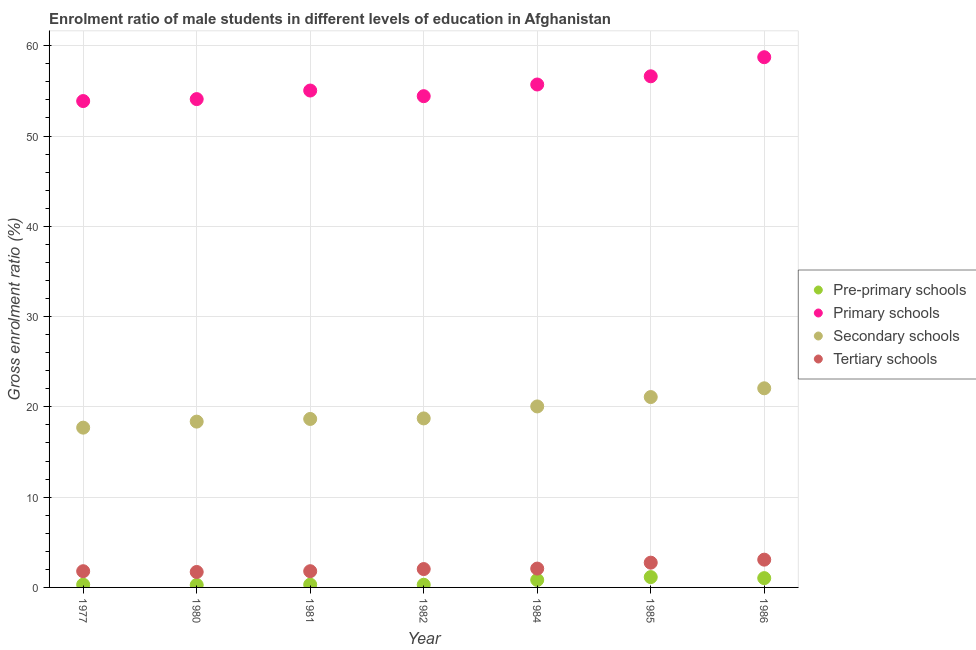What is the gross enrolment ratio(female) in pre-primary schools in 1985?
Ensure brevity in your answer.  1.14. Across all years, what is the maximum gross enrolment ratio(female) in secondary schools?
Your answer should be very brief. 22.06. Across all years, what is the minimum gross enrolment ratio(female) in pre-primary schools?
Offer a very short reply. 0.27. What is the total gross enrolment ratio(female) in secondary schools in the graph?
Provide a short and direct response. 136.64. What is the difference between the gross enrolment ratio(female) in tertiary schools in 1980 and that in 1981?
Offer a terse response. -0.09. What is the difference between the gross enrolment ratio(female) in secondary schools in 1981 and the gross enrolment ratio(female) in pre-primary schools in 1984?
Offer a terse response. 17.84. What is the average gross enrolment ratio(female) in tertiary schools per year?
Provide a succinct answer. 2.18. In the year 1986, what is the difference between the gross enrolment ratio(female) in secondary schools and gross enrolment ratio(female) in tertiary schools?
Your answer should be very brief. 18.98. In how many years, is the gross enrolment ratio(female) in tertiary schools greater than 12 %?
Your response must be concise. 0. What is the ratio of the gross enrolment ratio(female) in pre-primary schools in 1980 to that in 1982?
Provide a short and direct response. 0.92. Is the gross enrolment ratio(female) in pre-primary schools in 1980 less than that in 1986?
Provide a short and direct response. Yes. What is the difference between the highest and the second highest gross enrolment ratio(female) in pre-primary schools?
Keep it short and to the point. 0.12. What is the difference between the highest and the lowest gross enrolment ratio(female) in primary schools?
Offer a terse response. 4.86. In how many years, is the gross enrolment ratio(female) in secondary schools greater than the average gross enrolment ratio(female) in secondary schools taken over all years?
Give a very brief answer. 3. Is the sum of the gross enrolment ratio(female) in pre-primary schools in 1980 and 1985 greater than the maximum gross enrolment ratio(female) in tertiary schools across all years?
Offer a terse response. No. Is it the case that in every year, the sum of the gross enrolment ratio(female) in pre-primary schools and gross enrolment ratio(female) in secondary schools is greater than the sum of gross enrolment ratio(female) in primary schools and gross enrolment ratio(female) in tertiary schools?
Your answer should be compact. Yes. How many dotlines are there?
Your response must be concise. 4. What is the difference between two consecutive major ticks on the Y-axis?
Your response must be concise. 10. Does the graph contain grids?
Offer a very short reply. Yes. Where does the legend appear in the graph?
Ensure brevity in your answer.  Center right. How many legend labels are there?
Your answer should be very brief. 4. What is the title of the graph?
Your response must be concise. Enrolment ratio of male students in different levels of education in Afghanistan. Does "Methodology assessment" appear as one of the legend labels in the graph?
Provide a succinct answer. No. What is the label or title of the X-axis?
Provide a succinct answer. Year. What is the Gross enrolment ratio (%) of Pre-primary schools in 1977?
Give a very brief answer. 0.3. What is the Gross enrolment ratio (%) in Primary schools in 1977?
Offer a very short reply. 53.88. What is the Gross enrolment ratio (%) in Secondary schools in 1977?
Provide a succinct answer. 17.7. What is the Gross enrolment ratio (%) of Tertiary schools in 1977?
Offer a terse response. 1.8. What is the Gross enrolment ratio (%) in Pre-primary schools in 1980?
Give a very brief answer. 0.27. What is the Gross enrolment ratio (%) of Primary schools in 1980?
Keep it short and to the point. 54.09. What is the Gross enrolment ratio (%) in Secondary schools in 1980?
Provide a succinct answer. 18.37. What is the Gross enrolment ratio (%) of Tertiary schools in 1980?
Give a very brief answer. 1.71. What is the Gross enrolment ratio (%) in Pre-primary schools in 1981?
Offer a very short reply. 0.31. What is the Gross enrolment ratio (%) of Primary schools in 1981?
Make the answer very short. 55.04. What is the Gross enrolment ratio (%) in Secondary schools in 1981?
Offer a terse response. 18.66. What is the Gross enrolment ratio (%) of Tertiary schools in 1981?
Make the answer very short. 1.8. What is the Gross enrolment ratio (%) of Pre-primary schools in 1982?
Your answer should be compact. 0.29. What is the Gross enrolment ratio (%) in Primary schools in 1982?
Give a very brief answer. 54.42. What is the Gross enrolment ratio (%) of Secondary schools in 1982?
Keep it short and to the point. 18.72. What is the Gross enrolment ratio (%) of Tertiary schools in 1982?
Provide a succinct answer. 2.03. What is the Gross enrolment ratio (%) of Pre-primary schools in 1984?
Your answer should be compact. 0.83. What is the Gross enrolment ratio (%) of Primary schools in 1984?
Ensure brevity in your answer.  55.71. What is the Gross enrolment ratio (%) of Secondary schools in 1984?
Make the answer very short. 20.05. What is the Gross enrolment ratio (%) in Tertiary schools in 1984?
Give a very brief answer. 2.09. What is the Gross enrolment ratio (%) in Pre-primary schools in 1985?
Offer a terse response. 1.14. What is the Gross enrolment ratio (%) in Primary schools in 1985?
Provide a short and direct response. 56.62. What is the Gross enrolment ratio (%) in Secondary schools in 1985?
Offer a very short reply. 21.09. What is the Gross enrolment ratio (%) in Tertiary schools in 1985?
Your answer should be very brief. 2.74. What is the Gross enrolment ratio (%) of Pre-primary schools in 1986?
Your answer should be compact. 1.03. What is the Gross enrolment ratio (%) of Primary schools in 1986?
Ensure brevity in your answer.  58.73. What is the Gross enrolment ratio (%) of Secondary schools in 1986?
Your answer should be compact. 22.06. What is the Gross enrolment ratio (%) of Tertiary schools in 1986?
Your answer should be compact. 3.08. Across all years, what is the maximum Gross enrolment ratio (%) of Pre-primary schools?
Your answer should be compact. 1.14. Across all years, what is the maximum Gross enrolment ratio (%) of Primary schools?
Your response must be concise. 58.73. Across all years, what is the maximum Gross enrolment ratio (%) of Secondary schools?
Offer a terse response. 22.06. Across all years, what is the maximum Gross enrolment ratio (%) of Tertiary schools?
Provide a short and direct response. 3.08. Across all years, what is the minimum Gross enrolment ratio (%) in Pre-primary schools?
Give a very brief answer. 0.27. Across all years, what is the minimum Gross enrolment ratio (%) in Primary schools?
Your answer should be very brief. 53.88. Across all years, what is the minimum Gross enrolment ratio (%) of Secondary schools?
Provide a succinct answer. 17.7. Across all years, what is the minimum Gross enrolment ratio (%) in Tertiary schools?
Make the answer very short. 1.71. What is the total Gross enrolment ratio (%) in Pre-primary schools in the graph?
Offer a very short reply. 4.18. What is the total Gross enrolment ratio (%) in Primary schools in the graph?
Your response must be concise. 388.49. What is the total Gross enrolment ratio (%) in Secondary schools in the graph?
Provide a succinct answer. 136.64. What is the total Gross enrolment ratio (%) of Tertiary schools in the graph?
Make the answer very short. 15.25. What is the difference between the Gross enrolment ratio (%) in Pre-primary schools in 1977 and that in 1980?
Offer a terse response. 0.03. What is the difference between the Gross enrolment ratio (%) in Primary schools in 1977 and that in 1980?
Your answer should be compact. -0.22. What is the difference between the Gross enrolment ratio (%) in Secondary schools in 1977 and that in 1980?
Provide a succinct answer. -0.67. What is the difference between the Gross enrolment ratio (%) of Tertiary schools in 1977 and that in 1980?
Provide a succinct answer. 0.08. What is the difference between the Gross enrolment ratio (%) of Pre-primary schools in 1977 and that in 1981?
Ensure brevity in your answer.  -0. What is the difference between the Gross enrolment ratio (%) in Primary schools in 1977 and that in 1981?
Offer a very short reply. -1.17. What is the difference between the Gross enrolment ratio (%) in Secondary schools in 1977 and that in 1981?
Offer a terse response. -0.96. What is the difference between the Gross enrolment ratio (%) of Tertiary schools in 1977 and that in 1981?
Offer a terse response. -0. What is the difference between the Gross enrolment ratio (%) of Pre-primary schools in 1977 and that in 1982?
Provide a short and direct response. 0.01. What is the difference between the Gross enrolment ratio (%) of Primary schools in 1977 and that in 1982?
Your response must be concise. -0.54. What is the difference between the Gross enrolment ratio (%) of Secondary schools in 1977 and that in 1982?
Make the answer very short. -1.02. What is the difference between the Gross enrolment ratio (%) in Tertiary schools in 1977 and that in 1982?
Keep it short and to the point. -0.24. What is the difference between the Gross enrolment ratio (%) in Pre-primary schools in 1977 and that in 1984?
Make the answer very short. -0.52. What is the difference between the Gross enrolment ratio (%) in Primary schools in 1977 and that in 1984?
Your response must be concise. -1.83. What is the difference between the Gross enrolment ratio (%) of Secondary schools in 1977 and that in 1984?
Provide a short and direct response. -2.35. What is the difference between the Gross enrolment ratio (%) of Tertiary schools in 1977 and that in 1984?
Your answer should be very brief. -0.29. What is the difference between the Gross enrolment ratio (%) of Pre-primary schools in 1977 and that in 1985?
Keep it short and to the point. -0.84. What is the difference between the Gross enrolment ratio (%) in Primary schools in 1977 and that in 1985?
Make the answer very short. -2.74. What is the difference between the Gross enrolment ratio (%) in Secondary schools in 1977 and that in 1985?
Your answer should be very brief. -3.39. What is the difference between the Gross enrolment ratio (%) in Tertiary schools in 1977 and that in 1985?
Offer a very short reply. -0.95. What is the difference between the Gross enrolment ratio (%) in Pre-primary schools in 1977 and that in 1986?
Give a very brief answer. -0.72. What is the difference between the Gross enrolment ratio (%) in Primary schools in 1977 and that in 1986?
Your answer should be very brief. -4.86. What is the difference between the Gross enrolment ratio (%) in Secondary schools in 1977 and that in 1986?
Your response must be concise. -4.36. What is the difference between the Gross enrolment ratio (%) in Tertiary schools in 1977 and that in 1986?
Your answer should be very brief. -1.28. What is the difference between the Gross enrolment ratio (%) in Pre-primary schools in 1980 and that in 1981?
Provide a short and direct response. -0.04. What is the difference between the Gross enrolment ratio (%) of Primary schools in 1980 and that in 1981?
Offer a terse response. -0.95. What is the difference between the Gross enrolment ratio (%) in Secondary schools in 1980 and that in 1981?
Ensure brevity in your answer.  -0.3. What is the difference between the Gross enrolment ratio (%) in Tertiary schools in 1980 and that in 1981?
Provide a short and direct response. -0.09. What is the difference between the Gross enrolment ratio (%) of Pre-primary schools in 1980 and that in 1982?
Keep it short and to the point. -0.02. What is the difference between the Gross enrolment ratio (%) of Primary schools in 1980 and that in 1982?
Make the answer very short. -0.32. What is the difference between the Gross enrolment ratio (%) in Secondary schools in 1980 and that in 1982?
Make the answer very short. -0.35. What is the difference between the Gross enrolment ratio (%) in Tertiary schools in 1980 and that in 1982?
Your response must be concise. -0.32. What is the difference between the Gross enrolment ratio (%) in Pre-primary schools in 1980 and that in 1984?
Your answer should be compact. -0.56. What is the difference between the Gross enrolment ratio (%) of Primary schools in 1980 and that in 1984?
Give a very brief answer. -1.62. What is the difference between the Gross enrolment ratio (%) in Secondary schools in 1980 and that in 1984?
Provide a succinct answer. -1.68. What is the difference between the Gross enrolment ratio (%) of Tertiary schools in 1980 and that in 1984?
Give a very brief answer. -0.37. What is the difference between the Gross enrolment ratio (%) in Pre-primary schools in 1980 and that in 1985?
Keep it short and to the point. -0.87. What is the difference between the Gross enrolment ratio (%) in Primary schools in 1980 and that in 1985?
Your response must be concise. -2.53. What is the difference between the Gross enrolment ratio (%) in Secondary schools in 1980 and that in 1985?
Ensure brevity in your answer.  -2.72. What is the difference between the Gross enrolment ratio (%) in Tertiary schools in 1980 and that in 1985?
Offer a very short reply. -1.03. What is the difference between the Gross enrolment ratio (%) of Pre-primary schools in 1980 and that in 1986?
Your answer should be compact. -0.76. What is the difference between the Gross enrolment ratio (%) in Primary schools in 1980 and that in 1986?
Provide a succinct answer. -4.64. What is the difference between the Gross enrolment ratio (%) in Secondary schools in 1980 and that in 1986?
Ensure brevity in your answer.  -3.69. What is the difference between the Gross enrolment ratio (%) of Tertiary schools in 1980 and that in 1986?
Provide a short and direct response. -1.36. What is the difference between the Gross enrolment ratio (%) in Pre-primary schools in 1981 and that in 1982?
Keep it short and to the point. 0.01. What is the difference between the Gross enrolment ratio (%) in Secondary schools in 1981 and that in 1982?
Your response must be concise. -0.06. What is the difference between the Gross enrolment ratio (%) in Tertiary schools in 1981 and that in 1982?
Give a very brief answer. -0.24. What is the difference between the Gross enrolment ratio (%) in Pre-primary schools in 1981 and that in 1984?
Your answer should be very brief. -0.52. What is the difference between the Gross enrolment ratio (%) of Primary schools in 1981 and that in 1984?
Give a very brief answer. -0.67. What is the difference between the Gross enrolment ratio (%) of Secondary schools in 1981 and that in 1984?
Ensure brevity in your answer.  -1.39. What is the difference between the Gross enrolment ratio (%) of Tertiary schools in 1981 and that in 1984?
Make the answer very short. -0.29. What is the difference between the Gross enrolment ratio (%) in Pre-primary schools in 1981 and that in 1985?
Your answer should be very brief. -0.84. What is the difference between the Gross enrolment ratio (%) in Primary schools in 1981 and that in 1985?
Make the answer very short. -1.58. What is the difference between the Gross enrolment ratio (%) in Secondary schools in 1981 and that in 1985?
Give a very brief answer. -2.42. What is the difference between the Gross enrolment ratio (%) in Tertiary schools in 1981 and that in 1985?
Give a very brief answer. -0.95. What is the difference between the Gross enrolment ratio (%) of Pre-primary schools in 1981 and that in 1986?
Keep it short and to the point. -0.72. What is the difference between the Gross enrolment ratio (%) of Primary schools in 1981 and that in 1986?
Offer a terse response. -3.69. What is the difference between the Gross enrolment ratio (%) of Secondary schools in 1981 and that in 1986?
Your answer should be compact. -3.4. What is the difference between the Gross enrolment ratio (%) in Tertiary schools in 1981 and that in 1986?
Give a very brief answer. -1.28. What is the difference between the Gross enrolment ratio (%) of Pre-primary schools in 1982 and that in 1984?
Provide a short and direct response. -0.53. What is the difference between the Gross enrolment ratio (%) in Primary schools in 1982 and that in 1984?
Provide a short and direct response. -1.29. What is the difference between the Gross enrolment ratio (%) of Secondary schools in 1982 and that in 1984?
Offer a terse response. -1.33. What is the difference between the Gross enrolment ratio (%) of Tertiary schools in 1982 and that in 1984?
Your response must be concise. -0.05. What is the difference between the Gross enrolment ratio (%) of Pre-primary schools in 1982 and that in 1985?
Keep it short and to the point. -0.85. What is the difference between the Gross enrolment ratio (%) of Primary schools in 1982 and that in 1985?
Give a very brief answer. -2.2. What is the difference between the Gross enrolment ratio (%) in Secondary schools in 1982 and that in 1985?
Provide a short and direct response. -2.36. What is the difference between the Gross enrolment ratio (%) of Tertiary schools in 1982 and that in 1985?
Offer a very short reply. -0.71. What is the difference between the Gross enrolment ratio (%) of Pre-primary schools in 1982 and that in 1986?
Your response must be concise. -0.73. What is the difference between the Gross enrolment ratio (%) of Primary schools in 1982 and that in 1986?
Your response must be concise. -4.32. What is the difference between the Gross enrolment ratio (%) of Secondary schools in 1982 and that in 1986?
Provide a succinct answer. -3.34. What is the difference between the Gross enrolment ratio (%) of Tertiary schools in 1982 and that in 1986?
Ensure brevity in your answer.  -1.04. What is the difference between the Gross enrolment ratio (%) of Pre-primary schools in 1984 and that in 1985?
Ensure brevity in your answer.  -0.32. What is the difference between the Gross enrolment ratio (%) of Primary schools in 1984 and that in 1985?
Your response must be concise. -0.91. What is the difference between the Gross enrolment ratio (%) of Secondary schools in 1984 and that in 1985?
Make the answer very short. -1.04. What is the difference between the Gross enrolment ratio (%) of Tertiary schools in 1984 and that in 1985?
Offer a very short reply. -0.66. What is the difference between the Gross enrolment ratio (%) of Pre-primary schools in 1984 and that in 1986?
Offer a very short reply. -0.2. What is the difference between the Gross enrolment ratio (%) in Primary schools in 1984 and that in 1986?
Your response must be concise. -3.02. What is the difference between the Gross enrolment ratio (%) of Secondary schools in 1984 and that in 1986?
Your answer should be very brief. -2.01. What is the difference between the Gross enrolment ratio (%) of Tertiary schools in 1984 and that in 1986?
Give a very brief answer. -0.99. What is the difference between the Gross enrolment ratio (%) of Pre-primary schools in 1985 and that in 1986?
Your answer should be very brief. 0.12. What is the difference between the Gross enrolment ratio (%) of Primary schools in 1985 and that in 1986?
Your response must be concise. -2.11. What is the difference between the Gross enrolment ratio (%) of Secondary schools in 1985 and that in 1986?
Your response must be concise. -0.97. What is the difference between the Gross enrolment ratio (%) in Tertiary schools in 1985 and that in 1986?
Provide a short and direct response. -0.33. What is the difference between the Gross enrolment ratio (%) of Pre-primary schools in 1977 and the Gross enrolment ratio (%) of Primary schools in 1980?
Your answer should be very brief. -53.79. What is the difference between the Gross enrolment ratio (%) in Pre-primary schools in 1977 and the Gross enrolment ratio (%) in Secondary schools in 1980?
Ensure brevity in your answer.  -18.06. What is the difference between the Gross enrolment ratio (%) in Pre-primary schools in 1977 and the Gross enrolment ratio (%) in Tertiary schools in 1980?
Provide a succinct answer. -1.41. What is the difference between the Gross enrolment ratio (%) in Primary schools in 1977 and the Gross enrolment ratio (%) in Secondary schools in 1980?
Provide a short and direct response. 35.51. What is the difference between the Gross enrolment ratio (%) in Primary schools in 1977 and the Gross enrolment ratio (%) in Tertiary schools in 1980?
Keep it short and to the point. 52.16. What is the difference between the Gross enrolment ratio (%) in Secondary schools in 1977 and the Gross enrolment ratio (%) in Tertiary schools in 1980?
Your answer should be very brief. 15.99. What is the difference between the Gross enrolment ratio (%) in Pre-primary schools in 1977 and the Gross enrolment ratio (%) in Primary schools in 1981?
Ensure brevity in your answer.  -54.74. What is the difference between the Gross enrolment ratio (%) in Pre-primary schools in 1977 and the Gross enrolment ratio (%) in Secondary schools in 1981?
Offer a very short reply. -18.36. What is the difference between the Gross enrolment ratio (%) of Pre-primary schools in 1977 and the Gross enrolment ratio (%) of Tertiary schools in 1981?
Ensure brevity in your answer.  -1.49. What is the difference between the Gross enrolment ratio (%) in Primary schools in 1977 and the Gross enrolment ratio (%) in Secondary schools in 1981?
Provide a short and direct response. 35.21. What is the difference between the Gross enrolment ratio (%) of Primary schools in 1977 and the Gross enrolment ratio (%) of Tertiary schools in 1981?
Your answer should be compact. 52.08. What is the difference between the Gross enrolment ratio (%) in Secondary schools in 1977 and the Gross enrolment ratio (%) in Tertiary schools in 1981?
Your answer should be compact. 15.9. What is the difference between the Gross enrolment ratio (%) of Pre-primary schools in 1977 and the Gross enrolment ratio (%) of Primary schools in 1982?
Ensure brevity in your answer.  -54.11. What is the difference between the Gross enrolment ratio (%) in Pre-primary schools in 1977 and the Gross enrolment ratio (%) in Secondary schools in 1982?
Your answer should be compact. -18.42. What is the difference between the Gross enrolment ratio (%) in Pre-primary schools in 1977 and the Gross enrolment ratio (%) in Tertiary schools in 1982?
Your response must be concise. -1.73. What is the difference between the Gross enrolment ratio (%) in Primary schools in 1977 and the Gross enrolment ratio (%) in Secondary schools in 1982?
Your answer should be very brief. 35.15. What is the difference between the Gross enrolment ratio (%) of Primary schools in 1977 and the Gross enrolment ratio (%) of Tertiary schools in 1982?
Your answer should be very brief. 51.84. What is the difference between the Gross enrolment ratio (%) of Secondary schools in 1977 and the Gross enrolment ratio (%) of Tertiary schools in 1982?
Your response must be concise. 15.66. What is the difference between the Gross enrolment ratio (%) in Pre-primary schools in 1977 and the Gross enrolment ratio (%) in Primary schools in 1984?
Your response must be concise. -55.41. What is the difference between the Gross enrolment ratio (%) of Pre-primary schools in 1977 and the Gross enrolment ratio (%) of Secondary schools in 1984?
Your response must be concise. -19.74. What is the difference between the Gross enrolment ratio (%) in Pre-primary schools in 1977 and the Gross enrolment ratio (%) in Tertiary schools in 1984?
Ensure brevity in your answer.  -1.78. What is the difference between the Gross enrolment ratio (%) in Primary schools in 1977 and the Gross enrolment ratio (%) in Secondary schools in 1984?
Provide a succinct answer. 33.83. What is the difference between the Gross enrolment ratio (%) in Primary schools in 1977 and the Gross enrolment ratio (%) in Tertiary schools in 1984?
Provide a short and direct response. 51.79. What is the difference between the Gross enrolment ratio (%) of Secondary schools in 1977 and the Gross enrolment ratio (%) of Tertiary schools in 1984?
Offer a terse response. 15.61. What is the difference between the Gross enrolment ratio (%) of Pre-primary schools in 1977 and the Gross enrolment ratio (%) of Primary schools in 1985?
Give a very brief answer. -56.31. What is the difference between the Gross enrolment ratio (%) of Pre-primary schools in 1977 and the Gross enrolment ratio (%) of Secondary schools in 1985?
Offer a very short reply. -20.78. What is the difference between the Gross enrolment ratio (%) in Pre-primary schools in 1977 and the Gross enrolment ratio (%) in Tertiary schools in 1985?
Give a very brief answer. -2.44. What is the difference between the Gross enrolment ratio (%) of Primary schools in 1977 and the Gross enrolment ratio (%) of Secondary schools in 1985?
Give a very brief answer. 32.79. What is the difference between the Gross enrolment ratio (%) in Primary schools in 1977 and the Gross enrolment ratio (%) in Tertiary schools in 1985?
Your answer should be very brief. 51.13. What is the difference between the Gross enrolment ratio (%) in Secondary schools in 1977 and the Gross enrolment ratio (%) in Tertiary schools in 1985?
Provide a succinct answer. 14.96. What is the difference between the Gross enrolment ratio (%) in Pre-primary schools in 1977 and the Gross enrolment ratio (%) in Primary schools in 1986?
Your answer should be compact. -58.43. What is the difference between the Gross enrolment ratio (%) in Pre-primary schools in 1977 and the Gross enrolment ratio (%) in Secondary schools in 1986?
Provide a succinct answer. -21.75. What is the difference between the Gross enrolment ratio (%) in Pre-primary schools in 1977 and the Gross enrolment ratio (%) in Tertiary schools in 1986?
Your answer should be very brief. -2.77. What is the difference between the Gross enrolment ratio (%) in Primary schools in 1977 and the Gross enrolment ratio (%) in Secondary schools in 1986?
Provide a succinct answer. 31.82. What is the difference between the Gross enrolment ratio (%) of Primary schools in 1977 and the Gross enrolment ratio (%) of Tertiary schools in 1986?
Make the answer very short. 50.8. What is the difference between the Gross enrolment ratio (%) of Secondary schools in 1977 and the Gross enrolment ratio (%) of Tertiary schools in 1986?
Offer a very short reply. 14.62. What is the difference between the Gross enrolment ratio (%) in Pre-primary schools in 1980 and the Gross enrolment ratio (%) in Primary schools in 1981?
Ensure brevity in your answer.  -54.77. What is the difference between the Gross enrolment ratio (%) of Pre-primary schools in 1980 and the Gross enrolment ratio (%) of Secondary schools in 1981?
Offer a terse response. -18.39. What is the difference between the Gross enrolment ratio (%) of Pre-primary schools in 1980 and the Gross enrolment ratio (%) of Tertiary schools in 1981?
Your answer should be compact. -1.53. What is the difference between the Gross enrolment ratio (%) of Primary schools in 1980 and the Gross enrolment ratio (%) of Secondary schools in 1981?
Your response must be concise. 35.43. What is the difference between the Gross enrolment ratio (%) of Primary schools in 1980 and the Gross enrolment ratio (%) of Tertiary schools in 1981?
Ensure brevity in your answer.  52.29. What is the difference between the Gross enrolment ratio (%) in Secondary schools in 1980 and the Gross enrolment ratio (%) in Tertiary schools in 1981?
Provide a succinct answer. 16.57. What is the difference between the Gross enrolment ratio (%) of Pre-primary schools in 1980 and the Gross enrolment ratio (%) of Primary schools in 1982?
Your response must be concise. -54.15. What is the difference between the Gross enrolment ratio (%) of Pre-primary schools in 1980 and the Gross enrolment ratio (%) of Secondary schools in 1982?
Offer a terse response. -18.45. What is the difference between the Gross enrolment ratio (%) of Pre-primary schools in 1980 and the Gross enrolment ratio (%) of Tertiary schools in 1982?
Your answer should be very brief. -1.76. What is the difference between the Gross enrolment ratio (%) of Primary schools in 1980 and the Gross enrolment ratio (%) of Secondary schools in 1982?
Keep it short and to the point. 35.37. What is the difference between the Gross enrolment ratio (%) of Primary schools in 1980 and the Gross enrolment ratio (%) of Tertiary schools in 1982?
Make the answer very short. 52.06. What is the difference between the Gross enrolment ratio (%) in Secondary schools in 1980 and the Gross enrolment ratio (%) in Tertiary schools in 1982?
Your answer should be very brief. 16.33. What is the difference between the Gross enrolment ratio (%) in Pre-primary schools in 1980 and the Gross enrolment ratio (%) in Primary schools in 1984?
Give a very brief answer. -55.44. What is the difference between the Gross enrolment ratio (%) of Pre-primary schools in 1980 and the Gross enrolment ratio (%) of Secondary schools in 1984?
Your answer should be compact. -19.78. What is the difference between the Gross enrolment ratio (%) of Pre-primary schools in 1980 and the Gross enrolment ratio (%) of Tertiary schools in 1984?
Give a very brief answer. -1.82. What is the difference between the Gross enrolment ratio (%) of Primary schools in 1980 and the Gross enrolment ratio (%) of Secondary schools in 1984?
Keep it short and to the point. 34.04. What is the difference between the Gross enrolment ratio (%) of Primary schools in 1980 and the Gross enrolment ratio (%) of Tertiary schools in 1984?
Offer a very short reply. 52.01. What is the difference between the Gross enrolment ratio (%) in Secondary schools in 1980 and the Gross enrolment ratio (%) in Tertiary schools in 1984?
Offer a very short reply. 16.28. What is the difference between the Gross enrolment ratio (%) of Pre-primary schools in 1980 and the Gross enrolment ratio (%) of Primary schools in 1985?
Your answer should be very brief. -56.35. What is the difference between the Gross enrolment ratio (%) in Pre-primary schools in 1980 and the Gross enrolment ratio (%) in Secondary schools in 1985?
Offer a terse response. -20.82. What is the difference between the Gross enrolment ratio (%) of Pre-primary schools in 1980 and the Gross enrolment ratio (%) of Tertiary schools in 1985?
Keep it short and to the point. -2.47. What is the difference between the Gross enrolment ratio (%) of Primary schools in 1980 and the Gross enrolment ratio (%) of Secondary schools in 1985?
Keep it short and to the point. 33.01. What is the difference between the Gross enrolment ratio (%) of Primary schools in 1980 and the Gross enrolment ratio (%) of Tertiary schools in 1985?
Provide a short and direct response. 51.35. What is the difference between the Gross enrolment ratio (%) of Secondary schools in 1980 and the Gross enrolment ratio (%) of Tertiary schools in 1985?
Offer a terse response. 15.62. What is the difference between the Gross enrolment ratio (%) of Pre-primary schools in 1980 and the Gross enrolment ratio (%) of Primary schools in 1986?
Your response must be concise. -58.46. What is the difference between the Gross enrolment ratio (%) in Pre-primary schools in 1980 and the Gross enrolment ratio (%) in Secondary schools in 1986?
Make the answer very short. -21.79. What is the difference between the Gross enrolment ratio (%) of Pre-primary schools in 1980 and the Gross enrolment ratio (%) of Tertiary schools in 1986?
Give a very brief answer. -2.81. What is the difference between the Gross enrolment ratio (%) of Primary schools in 1980 and the Gross enrolment ratio (%) of Secondary schools in 1986?
Your answer should be very brief. 32.03. What is the difference between the Gross enrolment ratio (%) of Primary schools in 1980 and the Gross enrolment ratio (%) of Tertiary schools in 1986?
Keep it short and to the point. 51.02. What is the difference between the Gross enrolment ratio (%) in Secondary schools in 1980 and the Gross enrolment ratio (%) in Tertiary schools in 1986?
Your answer should be very brief. 15.29. What is the difference between the Gross enrolment ratio (%) in Pre-primary schools in 1981 and the Gross enrolment ratio (%) in Primary schools in 1982?
Your answer should be very brief. -54.11. What is the difference between the Gross enrolment ratio (%) in Pre-primary schools in 1981 and the Gross enrolment ratio (%) in Secondary schools in 1982?
Give a very brief answer. -18.41. What is the difference between the Gross enrolment ratio (%) in Pre-primary schools in 1981 and the Gross enrolment ratio (%) in Tertiary schools in 1982?
Make the answer very short. -1.73. What is the difference between the Gross enrolment ratio (%) in Primary schools in 1981 and the Gross enrolment ratio (%) in Secondary schools in 1982?
Your answer should be compact. 36.32. What is the difference between the Gross enrolment ratio (%) in Primary schools in 1981 and the Gross enrolment ratio (%) in Tertiary schools in 1982?
Your answer should be very brief. 53.01. What is the difference between the Gross enrolment ratio (%) in Secondary schools in 1981 and the Gross enrolment ratio (%) in Tertiary schools in 1982?
Ensure brevity in your answer.  16.63. What is the difference between the Gross enrolment ratio (%) in Pre-primary schools in 1981 and the Gross enrolment ratio (%) in Primary schools in 1984?
Make the answer very short. -55.4. What is the difference between the Gross enrolment ratio (%) of Pre-primary schools in 1981 and the Gross enrolment ratio (%) of Secondary schools in 1984?
Offer a terse response. -19.74. What is the difference between the Gross enrolment ratio (%) in Pre-primary schools in 1981 and the Gross enrolment ratio (%) in Tertiary schools in 1984?
Give a very brief answer. -1.78. What is the difference between the Gross enrolment ratio (%) of Primary schools in 1981 and the Gross enrolment ratio (%) of Secondary schools in 1984?
Your answer should be compact. 34.99. What is the difference between the Gross enrolment ratio (%) of Primary schools in 1981 and the Gross enrolment ratio (%) of Tertiary schools in 1984?
Your response must be concise. 52.96. What is the difference between the Gross enrolment ratio (%) in Secondary schools in 1981 and the Gross enrolment ratio (%) in Tertiary schools in 1984?
Make the answer very short. 16.58. What is the difference between the Gross enrolment ratio (%) of Pre-primary schools in 1981 and the Gross enrolment ratio (%) of Primary schools in 1985?
Your answer should be compact. -56.31. What is the difference between the Gross enrolment ratio (%) in Pre-primary schools in 1981 and the Gross enrolment ratio (%) in Secondary schools in 1985?
Ensure brevity in your answer.  -20.78. What is the difference between the Gross enrolment ratio (%) of Pre-primary schools in 1981 and the Gross enrolment ratio (%) of Tertiary schools in 1985?
Your response must be concise. -2.44. What is the difference between the Gross enrolment ratio (%) in Primary schools in 1981 and the Gross enrolment ratio (%) in Secondary schools in 1985?
Make the answer very short. 33.96. What is the difference between the Gross enrolment ratio (%) in Primary schools in 1981 and the Gross enrolment ratio (%) in Tertiary schools in 1985?
Your response must be concise. 52.3. What is the difference between the Gross enrolment ratio (%) of Secondary schools in 1981 and the Gross enrolment ratio (%) of Tertiary schools in 1985?
Keep it short and to the point. 15.92. What is the difference between the Gross enrolment ratio (%) of Pre-primary schools in 1981 and the Gross enrolment ratio (%) of Primary schools in 1986?
Ensure brevity in your answer.  -58.43. What is the difference between the Gross enrolment ratio (%) of Pre-primary schools in 1981 and the Gross enrolment ratio (%) of Secondary schools in 1986?
Provide a succinct answer. -21.75. What is the difference between the Gross enrolment ratio (%) in Pre-primary schools in 1981 and the Gross enrolment ratio (%) in Tertiary schools in 1986?
Provide a short and direct response. -2.77. What is the difference between the Gross enrolment ratio (%) of Primary schools in 1981 and the Gross enrolment ratio (%) of Secondary schools in 1986?
Provide a succinct answer. 32.98. What is the difference between the Gross enrolment ratio (%) of Primary schools in 1981 and the Gross enrolment ratio (%) of Tertiary schools in 1986?
Offer a very short reply. 51.97. What is the difference between the Gross enrolment ratio (%) of Secondary schools in 1981 and the Gross enrolment ratio (%) of Tertiary schools in 1986?
Give a very brief answer. 15.59. What is the difference between the Gross enrolment ratio (%) of Pre-primary schools in 1982 and the Gross enrolment ratio (%) of Primary schools in 1984?
Your response must be concise. -55.42. What is the difference between the Gross enrolment ratio (%) in Pre-primary schools in 1982 and the Gross enrolment ratio (%) in Secondary schools in 1984?
Give a very brief answer. -19.75. What is the difference between the Gross enrolment ratio (%) of Pre-primary schools in 1982 and the Gross enrolment ratio (%) of Tertiary schools in 1984?
Offer a terse response. -1.79. What is the difference between the Gross enrolment ratio (%) in Primary schools in 1982 and the Gross enrolment ratio (%) in Secondary schools in 1984?
Offer a very short reply. 34.37. What is the difference between the Gross enrolment ratio (%) of Primary schools in 1982 and the Gross enrolment ratio (%) of Tertiary schools in 1984?
Ensure brevity in your answer.  52.33. What is the difference between the Gross enrolment ratio (%) in Secondary schools in 1982 and the Gross enrolment ratio (%) in Tertiary schools in 1984?
Keep it short and to the point. 16.63. What is the difference between the Gross enrolment ratio (%) in Pre-primary schools in 1982 and the Gross enrolment ratio (%) in Primary schools in 1985?
Keep it short and to the point. -56.32. What is the difference between the Gross enrolment ratio (%) of Pre-primary schools in 1982 and the Gross enrolment ratio (%) of Secondary schools in 1985?
Your answer should be very brief. -20.79. What is the difference between the Gross enrolment ratio (%) of Pre-primary schools in 1982 and the Gross enrolment ratio (%) of Tertiary schools in 1985?
Make the answer very short. -2.45. What is the difference between the Gross enrolment ratio (%) of Primary schools in 1982 and the Gross enrolment ratio (%) of Secondary schools in 1985?
Your answer should be compact. 33.33. What is the difference between the Gross enrolment ratio (%) in Primary schools in 1982 and the Gross enrolment ratio (%) in Tertiary schools in 1985?
Provide a short and direct response. 51.67. What is the difference between the Gross enrolment ratio (%) of Secondary schools in 1982 and the Gross enrolment ratio (%) of Tertiary schools in 1985?
Your answer should be compact. 15.98. What is the difference between the Gross enrolment ratio (%) of Pre-primary schools in 1982 and the Gross enrolment ratio (%) of Primary schools in 1986?
Provide a short and direct response. -58.44. What is the difference between the Gross enrolment ratio (%) of Pre-primary schools in 1982 and the Gross enrolment ratio (%) of Secondary schools in 1986?
Provide a short and direct response. -21.76. What is the difference between the Gross enrolment ratio (%) in Pre-primary schools in 1982 and the Gross enrolment ratio (%) in Tertiary schools in 1986?
Give a very brief answer. -2.78. What is the difference between the Gross enrolment ratio (%) in Primary schools in 1982 and the Gross enrolment ratio (%) in Secondary schools in 1986?
Offer a very short reply. 32.36. What is the difference between the Gross enrolment ratio (%) of Primary schools in 1982 and the Gross enrolment ratio (%) of Tertiary schools in 1986?
Your answer should be compact. 51.34. What is the difference between the Gross enrolment ratio (%) of Secondary schools in 1982 and the Gross enrolment ratio (%) of Tertiary schools in 1986?
Provide a short and direct response. 15.64. What is the difference between the Gross enrolment ratio (%) in Pre-primary schools in 1984 and the Gross enrolment ratio (%) in Primary schools in 1985?
Give a very brief answer. -55.79. What is the difference between the Gross enrolment ratio (%) of Pre-primary schools in 1984 and the Gross enrolment ratio (%) of Secondary schools in 1985?
Keep it short and to the point. -20.26. What is the difference between the Gross enrolment ratio (%) of Pre-primary schools in 1984 and the Gross enrolment ratio (%) of Tertiary schools in 1985?
Offer a very short reply. -1.92. What is the difference between the Gross enrolment ratio (%) in Primary schools in 1984 and the Gross enrolment ratio (%) in Secondary schools in 1985?
Make the answer very short. 34.62. What is the difference between the Gross enrolment ratio (%) in Primary schools in 1984 and the Gross enrolment ratio (%) in Tertiary schools in 1985?
Your response must be concise. 52.97. What is the difference between the Gross enrolment ratio (%) in Secondary schools in 1984 and the Gross enrolment ratio (%) in Tertiary schools in 1985?
Make the answer very short. 17.3. What is the difference between the Gross enrolment ratio (%) in Pre-primary schools in 1984 and the Gross enrolment ratio (%) in Primary schools in 1986?
Your answer should be compact. -57.91. What is the difference between the Gross enrolment ratio (%) of Pre-primary schools in 1984 and the Gross enrolment ratio (%) of Secondary schools in 1986?
Give a very brief answer. -21.23. What is the difference between the Gross enrolment ratio (%) of Pre-primary schools in 1984 and the Gross enrolment ratio (%) of Tertiary schools in 1986?
Your answer should be compact. -2.25. What is the difference between the Gross enrolment ratio (%) in Primary schools in 1984 and the Gross enrolment ratio (%) in Secondary schools in 1986?
Your response must be concise. 33.65. What is the difference between the Gross enrolment ratio (%) of Primary schools in 1984 and the Gross enrolment ratio (%) of Tertiary schools in 1986?
Your answer should be very brief. 52.63. What is the difference between the Gross enrolment ratio (%) in Secondary schools in 1984 and the Gross enrolment ratio (%) in Tertiary schools in 1986?
Make the answer very short. 16.97. What is the difference between the Gross enrolment ratio (%) in Pre-primary schools in 1985 and the Gross enrolment ratio (%) in Primary schools in 1986?
Provide a succinct answer. -57.59. What is the difference between the Gross enrolment ratio (%) in Pre-primary schools in 1985 and the Gross enrolment ratio (%) in Secondary schools in 1986?
Provide a succinct answer. -20.91. What is the difference between the Gross enrolment ratio (%) in Pre-primary schools in 1985 and the Gross enrolment ratio (%) in Tertiary schools in 1986?
Offer a terse response. -1.93. What is the difference between the Gross enrolment ratio (%) in Primary schools in 1985 and the Gross enrolment ratio (%) in Secondary schools in 1986?
Make the answer very short. 34.56. What is the difference between the Gross enrolment ratio (%) of Primary schools in 1985 and the Gross enrolment ratio (%) of Tertiary schools in 1986?
Provide a succinct answer. 53.54. What is the difference between the Gross enrolment ratio (%) in Secondary schools in 1985 and the Gross enrolment ratio (%) in Tertiary schools in 1986?
Offer a terse response. 18.01. What is the average Gross enrolment ratio (%) of Pre-primary schools per year?
Your answer should be very brief. 0.6. What is the average Gross enrolment ratio (%) of Primary schools per year?
Your response must be concise. 55.5. What is the average Gross enrolment ratio (%) of Secondary schools per year?
Ensure brevity in your answer.  19.52. What is the average Gross enrolment ratio (%) of Tertiary schools per year?
Give a very brief answer. 2.18. In the year 1977, what is the difference between the Gross enrolment ratio (%) of Pre-primary schools and Gross enrolment ratio (%) of Primary schools?
Keep it short and to the point. -53.57. In the year 1977, what is the difference between the Gross enrolment ratio (%) of Pre-primary schools and Gross enrolment ratio (%) of Secondary schools?
Your response must be concise. -17.39. In the year 1977, what is the difference between the Gross enrolment ratio (%) of Pre-primary schools and Gross enrolment ratio (%) of Tertiary schools?
Your answer should be compact. -1.49. In the year 1977, what is the difference between the Gross enrolment ratio (%) of Primary schools and Gross enrolment ratio (%) of Secondary schools?
Offer a terse response. 36.18. In the year 1977, what is the difference between the Gross enrolment ratio (%) of Primary schools and Gross enrolment ratio (%) of Tertiary schools?
Make the answer very short. 52.08. In the year 1977, what is the difference between the Gross enrolment ratio (%) in Secondary schools and Gross enrolment ratio (%) in Tertiary schools?
Your response must be concise. 15.9. In the year 1980, what is the difference between the Gross enrolment ratio (%) in Pre-primary schools and Gross enrolment ratio (%) in Primary schools?
Your answer should be compact. -53.82. In the year 1980, what is the difference between the Gross enrolment ratio (%) in Pre-primary schools and Gross enrolment ratio (%) in Secondary schools?
Your answer should be very brief. -18.1. In the year 1980, what is the difference between the Gross enrolment ratio (%) of Pre-primary schools and Gross enrolment ratio (%) of Tertiary schools?
Keep it short and to the point. -1.44. In the year 1980, what is the difference between the Gross enrolment ratio (%) of Primary schools and Gross enrolment ratio (%) of Secondary schools?
Offer a very short reply. 35.73. In the year 1980, what is the difference between the Gross enrolment ratio (%) in Primary schools and Gross enrolment ratio (%) in Tertiary schools?
Provide a short and direct response. 52.38. In the year 1980, what is the difference between the Gross enrolment ratio (%) of Secondary schools and Gross enrolment ratio (%) of Tertiary schools?
Ensure brevity in your answer.  16.65. In the year 1981, what is the difference between the Gross enrolment ratio (%) of Pre-primary schools and Gross enrolment ratio (%) of Primary schools?
Offer a terse response. -54.73. In the year 1981, what is the difference between the Gross enrolment ratio (%) of Pre-primary schools and Gross enrolment ratio (%) of Secondary schools?
Give a very brief answer. -18.35. In the year 1981, what is the difference between the Gross enrolment ratio (%) of Pre-primary schools and Gross enrolment ratio (%) of Tertiary schools?
Offer a terse response. -1.49. In the year 1981, what is the difference between the Gross enrolment ratio (%) of Primary schools and Gross enrolment ratio (%) of Secondary schools?
Ensure brevity in your answer.  36.38. In the year 1981, what is the difference between the Gross enrolment ratio (%) of Primary schools and Gross enrolment ratio (%) of Tertiary schools?
Your answer should be very brief. 53.24. In the year 1981, what is the difference between the Gross enrolment ratio (%) of Secondary schools and Gross enrolment ratio (%) of Tertiary schools?
Offer a terse response. 16.86. In the year 1982, what is the difference between the Gross enrolment ratio (%) of Pre-primary schools and Gross enrolment ratio (%) of Primary schools?
Provide a succinct answer. -54.12. In the year 1982, what is the difference between the Gross enrolment ratio (%) of Pre-primary schools and Gross enrolment ratio (%) of Secondary schools?
Your answer should be compact. -18.43. In the year 1982, what is the difference between the Gross enrolment ratio (%) in Pre-primary schools and Gross enrolment ratio (%) in Tertiary schools?
Keep it short and to the point. -1.74. In the year 1982, what is the difference between the Gross enrolment ratio (%) of Primary schools and Gross enrolment ratio (%) of Secondary schools?
Offer a very short reply. 35.7. In the year 1982, what is the difference between the Gross enrolment ratio (%) of Primary schools and Gross enrolment ratio (%) of Tertiary schools?
Your answer should be compact. 52.38. In the year 1982, what is the difference between the Gross enrolment ratio (%) in Secondary schools and Gross enrolment ratio (%) in Tertiary schools?
Make the answer very short. 16.69. In the year 1984, what is the difference between the Gross enrolment ratio (%) of Pre-primary schools and Gross enrolment ratio (%) of Primary schools?
Give a very brief answer. -54.88. In the year 1984, what is the difference between the Gross enrolment ratio (%) in Pre-primary schools and Gross enrolment ratio (%) in Secondary schools?
Your answer should be compact. -19.22. In the year 1984, what is the difference between the Gross enrolment ratio (%) of Pre-primary schools and Gross enrolment ratio (%) of Tertiary schools?
Provide a succinct answer. -1.26. In the year 1984, what is the difference between the Gross enrolment ratio (%) in Primary schools and Gross enrolment ratio (%) in Secondary schools?
Your answer should be compact. 35.66. In the year 1984, what is the difference between the Gross enrolment ratio (%) in Primary schools and Gross enrolment ratio (%) in Tertiary schools?
Offer a terse response. 53.62. In the year 1984, what is the difference between the Gross enrolment ratio (%) in Secondary schools and Gross enrolment ratio (%) in Tertiary schools?
Your answer should be compact. 17.96. In the year 1985, what is the difference between the Gross enrolment ratio (%) of Pre-primary schools and Gross enrolment ratio (%) of Primary schools?
Offer a terse response. -55.47. In the year 1985, what is the difference between the Gross enrolment ratio (%) in Pre-primary schools and Gross enrolment ratio (%) in Secondary schools?
Make the answer very short. -19.94. In the year 1985, what is the difference between the Gross enrolment ratio (%) in Pre-primary schools and Gross enrolment ratio (%) in Tertiary schools?
Offer a very short reply. -1.6. In the year 1985, what is the difference between the Gross enrolment ratio (%) of Primary schools and Gross enrolment ratio (%) of Secondary schools?
Your answer should be very brief. 35.53. In the year 1985, what is the difference between the Gross enrolment ratio (%) of Primary schools and Gross enrolment ratio (%) of Tertiary schools?
Give a very brief answer. 53.88. In the year 1985, what is the difference between the Gross enrolment ratio (%) of Secondary schools and Gross enrolment ratio (%) of Tertiary schools?
Provide a short and direct response. 18.34. In the year 1986, what is the difference between the Gross enrolment ratio (%) in Pre-primary schools and Gross enrolment ratio (%) in Primary schools?
Your answer should be compact. -57.7. In the year 1986, what is the difference between the Gross enrolment ratio (%) of Pre-primary schools and Gross enrolment ratio (%) of Secondary schools?
Offer a very short reply. -21.03. In the year 1986, what is the difference between the Gross enrolment ratio (%) of Pre-primary schools and Gross enrolment ratio (%) of Tertiary schools?
Your answer should be compact. -2.05. In the year 1986, what is the difference between the Gross enrolment ratio (%) in Primary schools and Gross enrolment ratio (%) in Secondary schools?
Provide a short and direct response. 36.67. In the year 1986, what is the difference between the Gross enrolment ratio (%) of Primary schools and Gross enrolment ratio (%) of Tertiary schools?
Provide a short and direct response. 55.66. In the year 1986, what is the difference between the Gross enrolment ratio (%) of Secondary schools and Gross enrolment ratio (%) of Tertiary schools?
Keep it short and to the point. 18.98. What is the ratio of the Gross enrolment ratio (%) in Pre-primary schools in 1977 to that in 1980?
Provide a succinct answer. 1.13. What is the ratio of the Gross enrolment ratio (%) of Secondary schools in 1977 to that in 1980?
Your response must be concise. 0.96. What is the ratio of the Gross enrolment ratio (%) of Tertiary schools in 1977 to that in 1980?
Give a very brief answer. 1.05. What is the ratio of the Gross enrolment ratio (%) of Pre-primary schools in 1977 to that in 1981?
Offer a terse response. 0.99. What is the ratio of the Gross enrolment ratio (%) of Primary schools in 1977 to that in 1981?
Your response must be concise. 0.98. What is the ratio of the Gross enrolment ratio (%) in Secondary schools in 1977 to that in 1981?
Provide a short and direct response. 0.95. What is the ratio of the Gross enrolment ratio (%) of Tertiary schools in 1977 to that in 1981?
Your answer should be very brief. 1. What is the ratio of the Gross enrolment ratio (%) in Pre-primary schools in 1977 to that in 1982?
Offer a terse response. 1.04. What is the ratio of the Gross enrolment ratio (%) of Primary schools in 1977 to that in 1982?
Provide a succinct answer. 0.99. What is the ratio of the Gross enrolment ratio (%) in Secondary schools in 1977 to that in 1982?
Your response must be concise. 0.95. What is the ratio of the Gross enrolment ratio (%) in Tertiary schools in 1977 to that in 1982?
Offer a very short reply. 0.88. What is the ratio of the Gross enrolment ratio (%) of Pre-primary schools in 1977 to that in 1984?
Give a very brief answer. 0.37. What is the ratio of the Gross enrolment ratio (%) of Primary schools in 1977 to that in 1984?
Give a very brief answer. 0.97. What is the ratio of the Gross enrolment ratio (%) of Secondary schools in 1977 to that in 1984?
Your response must be concise. 0.88. What is the ratio of the Gross enrolment ratio (%) of Tertiary schools in 1977 to that in 1984?
Provide a succinct answer. 0.86. What is the ratio of the Gross enrolment ratio (%) of Pre-primary schools in 1977 to that in 1985?
Your answer should be compact. 0.27. What is the ratio of the Gross enrolment ratio (%) of Primary schools in 1977 to that in 1985?
Your answer should be very brief. 0.95. What is the ratio of the Gross enrolment ratio (%) of Secondary schools in 1977 to that in 1985?
Make the answer very short. 0.84. What is the ratio of the Gross enrolment ratio (%) of Tertiary schools in 1977 to that in 1985?
Provide a succinct answer. 0.66. What is the ratio of the Gross enrolment ratio (%) in Pre-primary schools in 1977 to that in 1986?
Provide a short and direct response. 0.3. What is the ratio of the Gross enrolment ratio (%) of Primary schools in 1977 to that in 1986?
Provide a short and direct response. 0.92. What is the ratio of the Gross enrolment ratio (%) of Secondary schools in 1977 to that in 1986?
Your response must be concise. 0.8. What is the ratio of the Gross enrolment ratio (%) of Tertiary schools in 1977 to that in 1986?
Give a very brief answer. 0.58. What is the ratio of the Gross enrolment ratio (%) of Pre-primary schools in 1980 to that in 1981?
Offer a terse response. 0.88. What is the ratio of the Gross enrolment ratio (%) in Primary schools in 1980 to that in 1981?
Your answer should be very brief. 0.98. What is the ratio of the Gross enrolment ratio (%) of Secondary schools in 1980 to that in 1981?
Your answer should be very brief. 0.98. What is the ratio of the Gross enrolment ratio (%) of Tertiary schools in 1980 to that in 1981?
Ensure brevity in your answer.  0.95. What is the ratio of the Gross enrolment ratio (%) in Pre-primary schools in 1980 to that in 1982?
Your response must be concise. 0.92. What is the ratio of the Gross enrolment ratio (%) in Primary schools in 1980 to that in 1982?
Provide a short and direct response. 0.99. What is the ratio of the Gross enrolment ratio (%) in Secondary schools in 1980 to that in 1982?
Make the answer very short. 0.98. What is the ratio of the Gross enrolment ratio (%) in Tertiary schools in 1980 to that in 1982?
Your answer should be very brief. 0.84. What is the ratio of the Gross enrolment ratio (%) of Pre-primary schools in 1980 to that in 1984?
Make the answer very short. 0.33. What is the ratio of the Gross enrolment ratio (%) in Secondary schools in 1980 to that in 1984?
Offer a terse response. 0.92. What is the ratio of the Gross enrolment ratio (%) in Tertiary schools in 1980 to that in 1984?
Keep it short and to the point. 0.82. What is the ratio of the Gross enrolment ratio (%) in Pre-primary schools in 1980 to that in 1985?
Offer a terse response. 0.24. What is the ratio of the Gross enrolment ratio (%) of Primary schools in 1980 to that in 1985?
Your answer should be compact. 0.96. What is the ratio of the Gross enrolment ratio (%) of Secondary schools in 1980 to that in 1985?
Make the answer very short. 0.87. What is the ratio of the Gross enrolment ratio (%) in Tertiary schools in 1980 to that in 1985?
Provide a succinct answer. 0.62. What is the ratio of the Gross enrolment ratio (%) in Pre-primary schools in 1980 to that in 1986?
Provide a short and direct response. 0.26. What is the ratio of the Gross enrolment ratio (%) of Primary schools in 1980 to that in 1986?
Give a very brief answer. 0.92. What is the ratio of the Gross enrolment ratio (%) of Secondary schools in 1980 to that in 1986?
Provide a succinct answer. 0.83. What is the ratio of the Gross enrolment ratio (%) of Tertiary schools in 1980 to that in 1986?
Make the answer very short. 0.56. What is the ratio of the Gross enrolment ratio (%) in Pre-primary schools in 1981 to that in 1982?
Your answer should be very brief. 1.04. What is the ratio of the Gross enrolment ratio (%) of Primary schools in 1981 to that in 1982?
Your response must be concise. 1.01. What is the ratio of the Gross enrolment ratio (%) of Secondary schools in 1981 to that in 1982?
Keep it short and to the point. 1. What is the ratio of the Gross enrolment ratio (%) of Tertiary schools in 1981 to that in 1982?
Your answer should be compact. 0.88. What is the ratio of the Gross enrolment ratio (%) in Pre-primary schools in 1981 to that in 1984?
Ensure brevity in your answer.  0.37. What is the ratio of the Gross enrolment ratio (%) of Primary schools in 1981 to that in 1984?
Offer a very short reply. 0.99. What is the ratio of the Gross enrolment ratio (%) in Secondary schools in 1981 to that in 1984?
Offer a terse response. 0.93. What is the ratio of the Gross enrolment ratio (%) in Tertiary schools in 1981 to that in 1984?
Your response must be concise. 0.86. What is the ratio of the Gross enrolment ratio (%) in Pre-primary schools in 1981 to that in 1985?
Your response must be concise. 0.27. What is the ratio of the Gross enrolment ratio (%) of Primary schools in 1981 to that in 1985?
Your answer should be compact. 0.97. What is the ratio of the Gross enrolment ratio (%) in Secondary schools in 1981 to that in 1985?
Ensure brevity in your answer.  0.89. What is the ratio of the Gross enrolment ratio (%) of Tertiary schools in 1981 to that in 1985?
Provide a succinct answer. 0.66. What is the ratio of the Gross enrolment ratio (%) of Pre-primary schools in 1981 to that in 1986?
Provide a short and direct response. 0.3. What is the ratio of the Gross enrolment ratio (%) in Primary schools in 1981 to that in 1986?
Your response must be concise. 0.94. What is the ratio of the Gross enrolment ratio (%) in Secondary schools in 1981 to that in 1986?
Give a very brief answer. 0.85. What is the ratio of the Gross enrolment ratio (%) in Tertiary schools in 1981 to that in 1986?
Ensure brevity in your answer.  0.58. What is the ratio of the Gross enrolment ratio (%) in Pre-primary schools in 1982 to that in 1984?
Your response must be concise. 0.36. What is the ratio of the Gross enrolment ratio (%) of Primary schools in 1982 to that in 1984?
Your answer should be very brief. 0.98. What is the ratio of the Gross enrolment ratio (%) in Secondary schools in 1982 to that in 1984?
Provide a succinct answer. 0.93. What is the ratio of the Gross enrolment ratio (%) of Pre-primary schools in 1982 to that in 1985?
Provide a succinct answer. 0.26. What is the ratio of the Gross enrolment ratio (%) in Primary schools in 1982 to that in 1985?
Make the answer very short. 0.96. What is the ratio of the Gross enrolment ratio (%) of Secondary schools in 1982 to that in 1985?
Your answer should be very brief. 0.89. What is the ratio of the Gross enrolment ratio (%) in Tertiary schools in 1982 to that in 1985?
Offer a very short reply. 0.74. What is the ratio of the Gross enrolment ratio (%) of Pre-primary schools in 1982 to that in 1986?
Your response must be concise. 0.29. What is the ratio of the Gross enrolment ratio (%) in Primary schools in 1982 to that in 1986?
Offer a terse response. 0.93. What is the ratio of the Gross enrolment ratio (%) of Secondary schools in 1982 to that in 1986?
Ensure brevity in your answer.  0.85. What is the ratio of the Gross enrolment ratio (%) in Tertiary schools in 1982 to that in 1986?
Ensure brevity in your answer.  0.66. What is the ratio of the Gross enrolment ratio (%) in Pre-primary schools in 1984 to that in 1985?
Your response must be concise. 0.72. What is the ratio of the Gross enrolment ratio (%) in Secondary schools in 1984 to that in 1985?
Ensure brevity in your answer.  0.95. What is the ratio of the Gross enrolment ratio (%) in Tertiary schools in 1984 to that in 1985?
Your answer should be compact. 0.76. What is the ratio of the Gross enrolment ratio (%) of Pre-primary schools in 1984 to that in 1986?
Offer a very short reply. 0.8. What is the ratio of the Gross enrolment ratio (%) in Primary schools in 1984 to that in 1986?
Your response must be concise. 0.95. What is the ratio of the Gross enrolment ratio (%) in Secondary schools in 1984 to that in 1986?
Your answer should be very brief. 0.91. What is the ratio of the Gross enrolment ratio (%) of Tertiary schools in 1984 to that in 1986?
Give a very brief answer. 0.68. What is the ratio of the Gross enrolment ratio (%) of Pre-primary schools in 1985 to that in 1986?
Provide a short and direct response. 1.11. What is the ratio of the Gross enrolment ratio (%) in Secondary schools in 1985 to that in 1986?
Make the answer very short. 0.96. What is the ratio of the Gross enrolment ratio (%) in Tertiary schools in 1985 to that in 1986?
Make the answer very short. 0.89. What is the difference between the highest and the second highest Gross enrolment ratio (%) in Pre-primary schools?
Provide a succinct answer. 0.12. What is the difference between the highest and the second highest Gross enrolment ratio (%) in Primary schools?
Keep it short and to the point. 2.11. What is the difference between the highest and the second highest Gross enrolment ratio (%) in Secondary schools?
Provide a succinct answer. 0.97. What is the difference between the highest and the second highest Gross enrolment ratio (%) of Tertiary schools?
Offer a very short reply. 0.33. What is the difference between the highest and the lowest Gross enrolment ratio (%) in Pre-primary schools?
Offer a very short reply. 0.87. What is the difference between the highest and the lowest Gross enrolment ratio (%) of Primary schools?
Offer a terse response. 4.86. What is the difference between the highest and the lowest Gross enrolment ratio (%) of Secondary schools?
Give a very brief answer. 4.36. What is the difference between the highest and the lowest Gross enrolment ratio (%) in Tertiary schools?
Offer a very short reply. 1.36. 